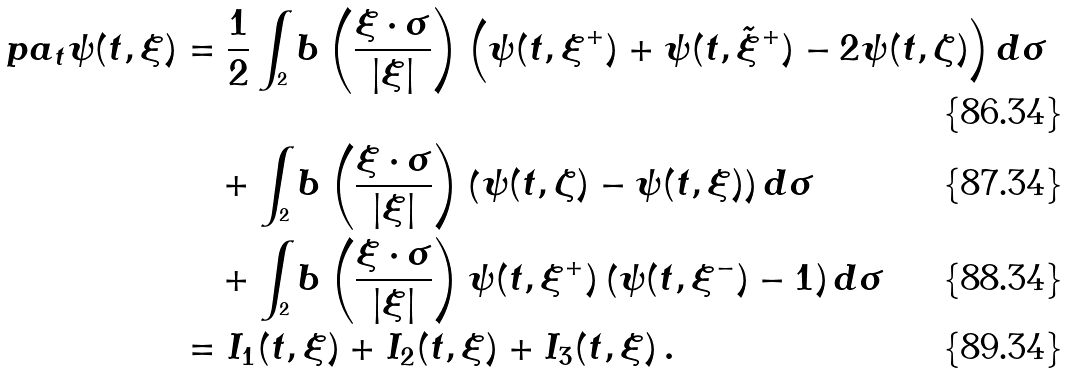Convert formula to latex. <formula><loc_0><loc_0><loc_500><loc_500>\ p a _ { t } \psi ( t , \xi ) & = \frac { 1 } { 2 } \int _ { ^ { 2 } } b \left ( \frac { \xi \cdot \sigma } { | \xi | } \right ) \left ( \psi ( t , \xi ^ { + } ) + \psi ( t , \tilde { \xi } ^ { + } ) - 2 \psi ( t , \zeta ) \right ) d \sigma \\ & \quad + \int _ { ^ { 2 } } b \left ( \frac { \xi \cdot \sigma } { | \xi | } \right ) \left ( \psi ( t , \zeta ) - \psi ( t , \xi ) \right ) d \sigma \\ & \quad + \int _ { ^ { 2 } } b \left ( \frac { \xi \cdot \sigma } { | \xi | } \right ) \psi ( t , \xi ^ { + } ) \left ( \psi ( t , \xi ^ { - } ) - 1 \right ) d \sigma \\ & = I _ { 1 } ( t , \xi ) + I _ { 2 } ( t , \xi ) + I _ { 3 } ( t , \xi ) \, .</formula> 